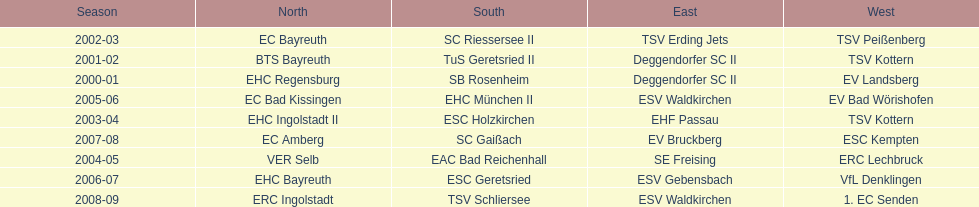Parse the full table. {'header': ['Season', 'North', 'South', 'East', 'West'], 'rows': [['2002-03', 'EC Bayreuth', 'SC Riessersee II', 'TSV Erding Jets', 'TSV Peißenberg'], ['2001-02', 'BTS Bayreuth', 'TuS Geretsried II', 'Deggendorfer SC II', 'TSV Kottern'], ['2000-01', 'EHC Regensburg', 'SB Rosenheim', 'Deggendorfer SC II', 'EV Landsberg'], ['2005-06', 'EC Bad Kissingen', 'EHC München II', 'ESV Waldkirchen', 'EV Bad Wörishofen'], ['2003-04', 'EHC Ingolstadt II', 'ESC Holzkirchen', 'EHF Passau', 'TSV Kottern'], ['2007-08', 'EC Amberg', 'SC Gaißach', 'EV Bruckberg', 'ESC Kempten'], ['2004-05', 'VER Selb', 'EAC Bad Reichenhall', 'SE Freising', 'ERC Lechbruck'], ['2006-07', 'EHC Bayreuth', 'ESC Geretsried', 'ESV Gebensbach', 'VfL Denklingen'], ['2008-09', 'ERC Ingolstadt', 'TSV Schliersee', 'ESV Waldkirchen', '1. EC Senden']]} How many champions are listend in the north? 9. 